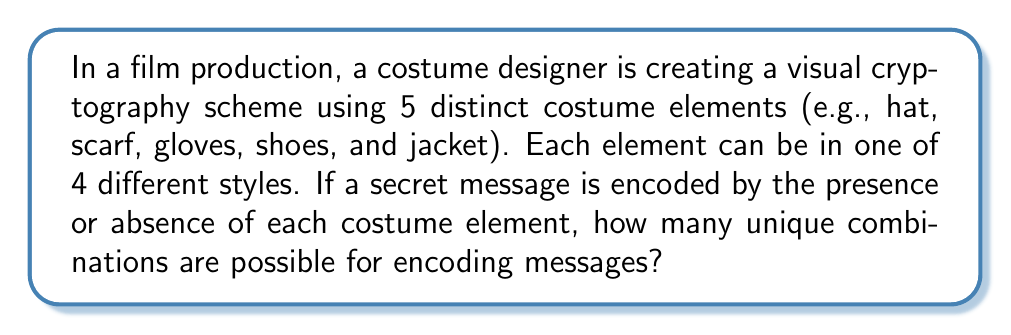What is the answer to this math problem? Let's approach this step-by-step:

1) We have 5 distinct costume elements, each of which can be either present or absent in the final costume. This gives us 2 options for each element.

2) For each present element, we have 4 different style options.

3) We can represent this mathematically as follows:
   For each element: $$(1 \text{ absence option}) + (1 \text{ presence option} \times 4 \text{ style options}) = 5 \text{ total options}$$

4) Since we have 5 independent elements, and for each element we have 5 options, we can use the multiplication principle.

5) The total number of combinations is therefore:

   $$5 \times 5 \times 5 \times 5 \times 5 = 5^5$$

6) Calculating this:
   $$5^5 = 3125$$

Thus, there are 3125 possible unique combinations for encoding messages using this costume-based visual cryptography scheme.
Answer: 3125 